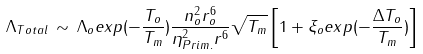Convert formula to latex. <formula><loc_0><loc_0><loc_500><loc_500>\Lambda _ { T o t a l } \, \sim \, \Lambda _ { o } e x p ( - \frac { T _ { o } } { T _ { m } } ) \frac { n _ { o } ^ { 2 } r _ { o } ^ { 6 } } { \eta _ { P r i m . } ^ { 2 } r ^ { 6 } } \sqrt { T _ { m } } \left [ 1 + \xi _ { o } e x p ( - \frac { \Delta T _ { o } } { T _ { m } } ) \right ]</formula> 